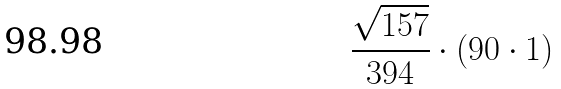Convert formula to latex. <formula><loc_0><loc_0><loc_500><loc_500>\frac { \sqrt { 1 5 7 } } { 3 9 4 } \cdot ( 9 0 \cdot 1 )</formula> 